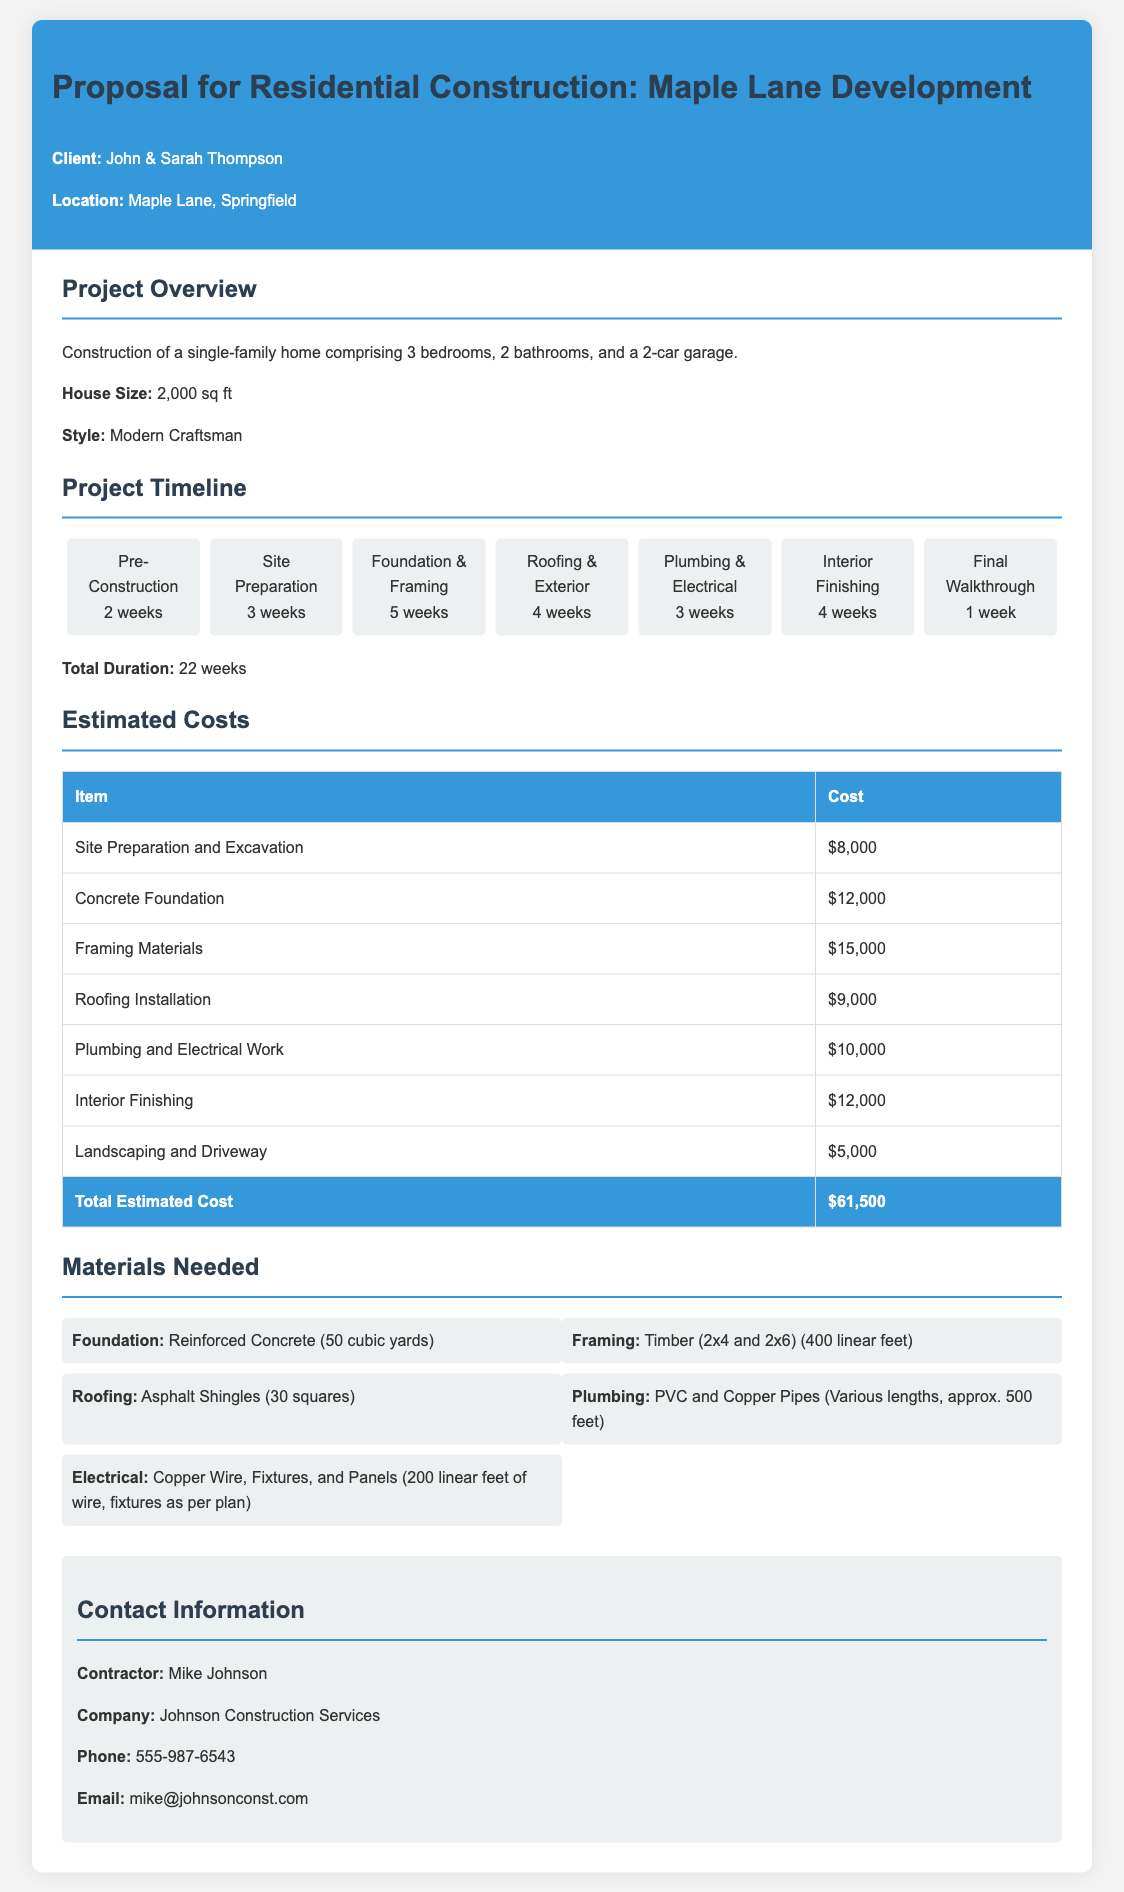What is the total estimated cost? The total estimated cost is provided in the document as a sum of all project costs.
Answer: $61,500 How many bedrooms does the house have? The document specifies the number of bedrooms in the project overview section.
Answer: 3 bedrooms What is the style of the house? The style of the house is mentioned in the project overview section.
Answer: Modern Craftsman How long is the pre-construction phase? The pre-construction timeline is listed in the timeline section of the document.
Answer: 2 weeks What materials are needed for plumbing? The document lists the required materials under the materials needed section.
Answer: PVC and Copper Pipes How many weeks is the total project duration? The total project duration is summarized at the end of the timeline section.
Answer: 22 weeks Who is the contractor for this project? The contractor's name is given in the contact information section.
Answer: Mike Johnson What is the estimated cost for roofing installation? The estimated cost for roofing installation is found in the cost estimate table.
Answer: $9,000 